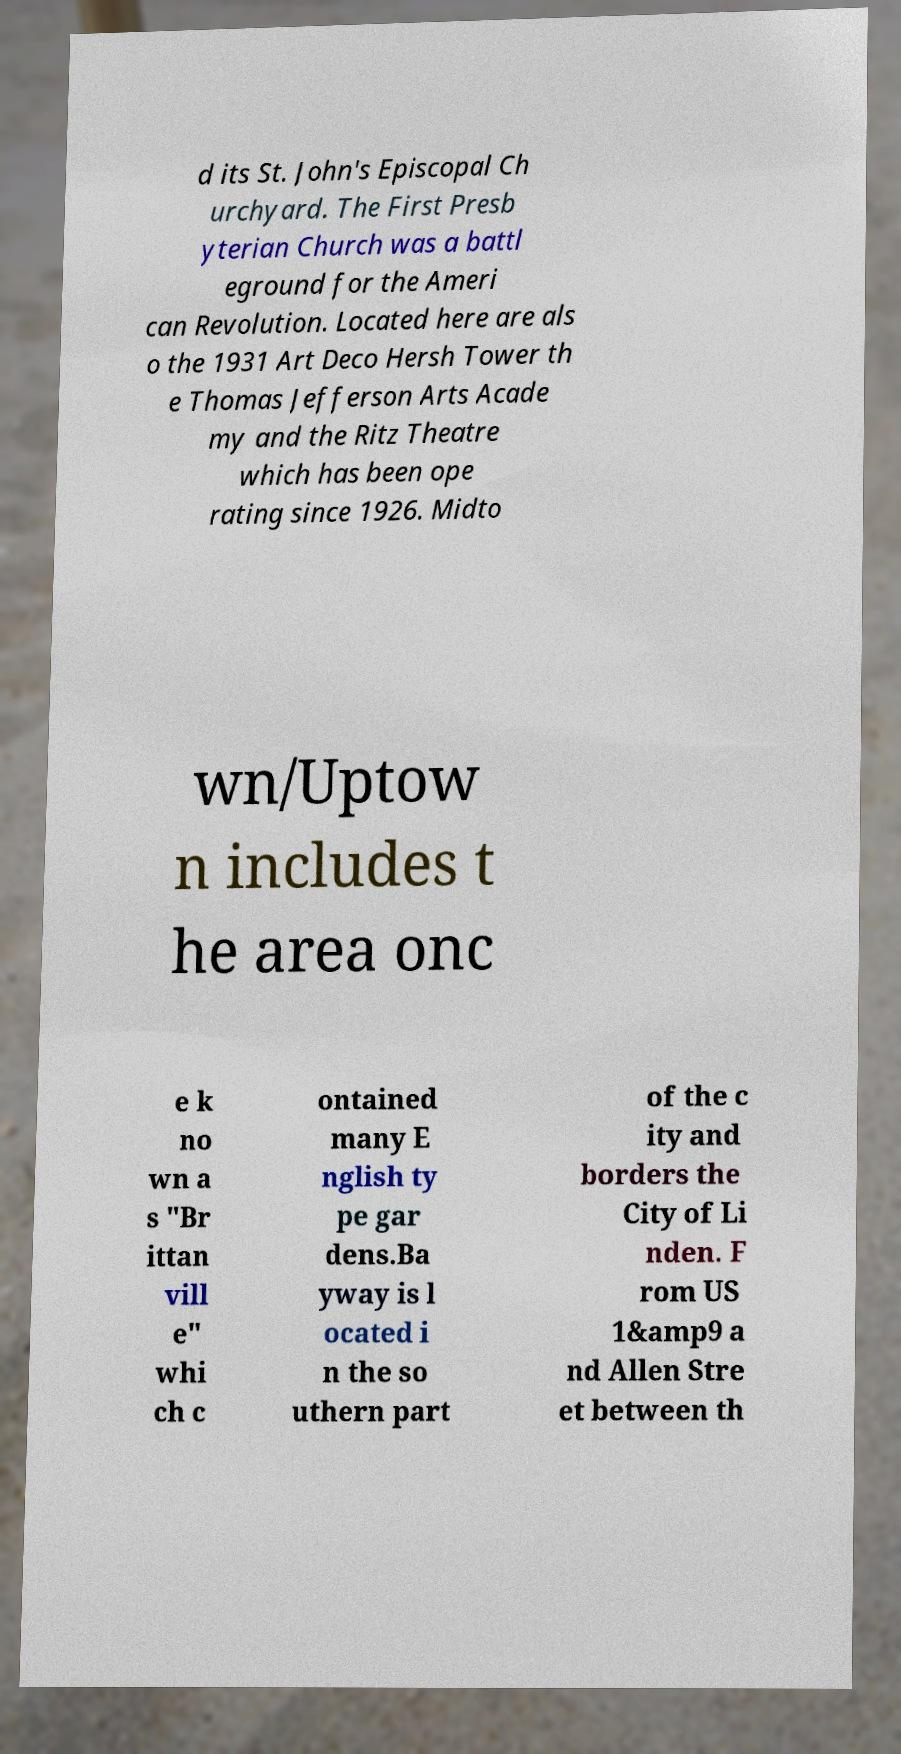There's text embedded in this image that I need extracted. Can you transcribe it verbatim? d its St. John's Episcopal Ch urchyard. The First Presb yterian Church was a battl eground for the Ameri can Revolution. Located here are als o the 1931 Art Deco Hersh Tower th e Thomas Jefferson Arts Acade my and the Ritz Theatre which has been ope rating since 1926. Midto wn/Uptow n includes t he area onc e k no wn a s "Br ittan vill e" whi ch c ontained many E nglish ty pe gar dens.Ba yway is l ocated i n the so uthern part of the c ity and borders the City of Li nden. F rom US 1&amp9 a nd Allen Stre et between th 